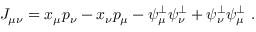<formula> <loc_0><loc_0><loc_500><loc_500>J _ { \mu \nu } = x _ { \mu } p _ { \nu } - x _ { \nu } p _ { \mu } - \psi _ { \mu } ^ { \perp } \psi _ { \nu } ^ { \perp } + \psi _ { \nu } ^ { \perp } \psi _ { \mu } ^ { \perp } \ .</formula> 